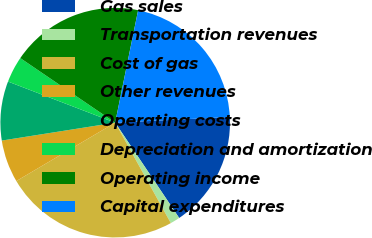Convert chart to OTSL. <chart><loc_0><loc_0><loc_500><loc_500><pie_chart><fcel>Gas sales<fcel>Transportation revenues<fcel>Cost of gas<fcel>Other revenues<fcel>Operating costs<fcel>Depreciation and amortization<fcel>Operating income<fcel>Capital expenditures<nl><fcel>16.37%<fcel>1.36%<fcel>24.56%<fcel>6.0%<fcel>8.32%<fcel>3.68%<fcel>18.69%<fcel>21.01%<nl></chart> 